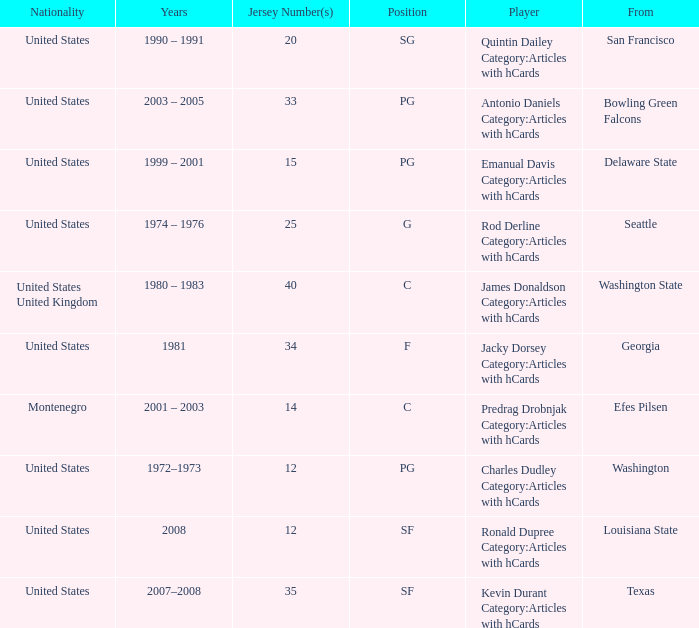What years did the united states player with a jersey number 25 who attended delaware state play? 1999 – 2001. 